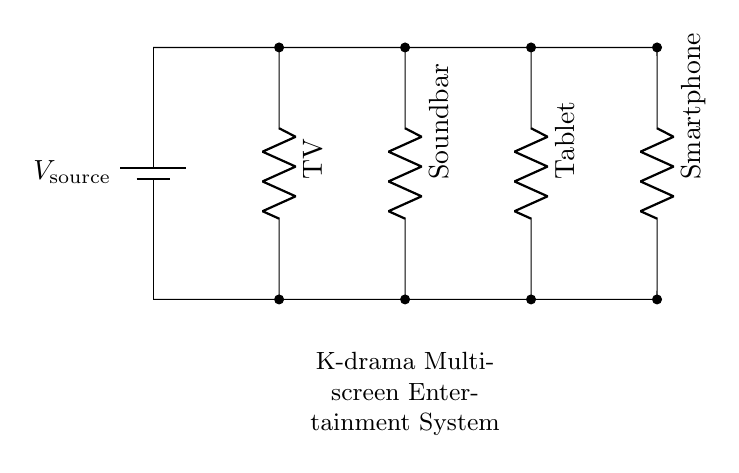What is the total number of components in the circuit? The circuit diagram shows four resistive components labeled as TV, Soundbar, Tablet, and Smartphone connected in parallel. Adding these components gives a total number of four.
Answer: four What is the role of the battery in this circuit? The battery provides the voltage supply (source voltage) necessary for all the connected components in the circuit to operate. In parallel circuits, each component receives the same voltage from the battery.
Answer: voltage source How many resistive loads are parallel to each other? The circuit displays four loads each connected in parallel form. In these types of configurations, the parallel arrangement allows each load to operate independently while sharing the same voltage source.
Answer: four What is the common voltage applied across all components? Since the circuit is powered by a single battery source, the voltage applied across each of the components (TV, Soundbar, Tablet, Smartphone) is equal to the source voltage provided by the battery.
Answer: V source If one component fails, how do the other components behave? In a parallel circuit, if one component fails or is disconnected, the remaining components continue to operate normally. This design feature allows for uninterrupted service of the functioning components even if one fails.
Answer: remains functional Which device is the farthest from the battery? The Smartphone is positioned at the far right end of the circuit diagram, making it the device that is spatially furthest from the battery source located at the left side.
Answer: Smartphone 